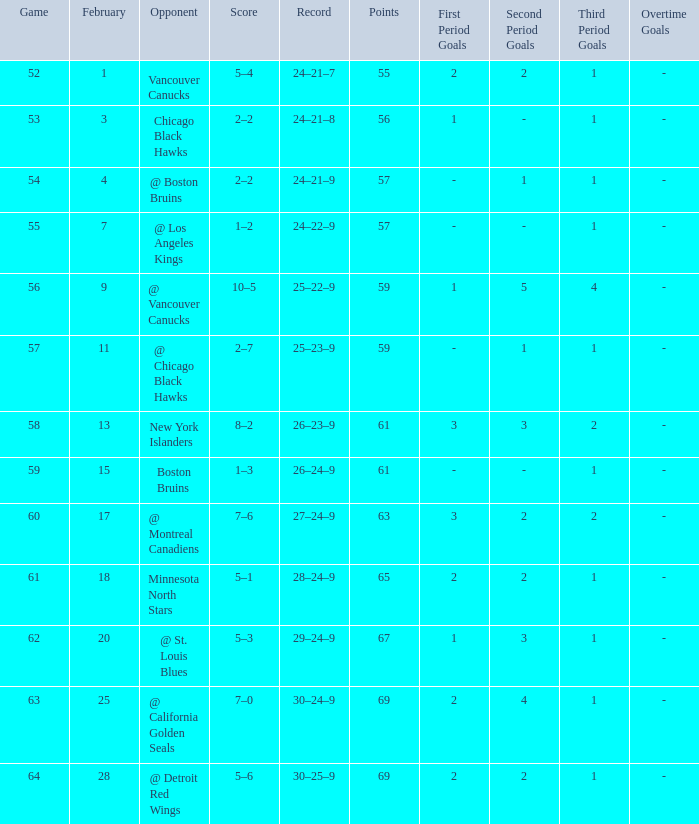Would you mind parsing the complete table? {'header': ['Game', 'February', 'Opponent', 'Score', 'Record', 'Points', 'First Period Goals', 'Second Period Goals', 'Third Period Goals', 'Overtime Goals'], 'rows': [['52', '1', 'Vancouver Canucks', '5–4', '24–21–7', '55', '2', '2', '1', '-'], ['53', '3', 'Chicago Black Hawks', '2–2', '24–21–8', '56', '1', '-', '1', '-'], ['54', '4', '@ Boston Bruins', '2–2', '24–21–9', '57', '-', '1', '1', '-'], ['55', '7', '@ Los Angeles Kings', '1–2', '24–22–9', '57', '-', '-', '1', '-'], ['56', '9', '@ Vancouver Canucks', '10–5', '25–22–9', '59', '1', '5', '4', '-'], ['57', '11', '@ Chicago Black Hawks', '2–7', '25–23–9', '59', '-', '1', '1', '-'], ['58', '13', 'New York Islanders', '8–2', '26–23–9', '61', '3', '3', '2', '-'], ['59', '15', 'Boston Bruins', '1–3', '26–24–9', '61', '-', '-', '1', '-'], ['60', '17', '@ Montreal Canadiens', '7–6', '27–24–9', '63', '3', '2', '2', '-'], ['61', '18', 'Minnesota North Stars', '5–1', '28–24–9', '65', '2', '2', '1', '-'], ['62', '20', '@ St. Louis Blues', '5–3', '29–24–9', '67', '1', '3', '1', '-'], ['63', '25', '@ California Golden Seals', '7–0', '30–24–9', '69', '2', '4', '1', '-'], ['64', '28', '@ Detroit Red Wings', '5–6', '30–25–9', '69', '2', '2', '1', '-']]} How many february matches had a record of 29-24-9? 20.0. 